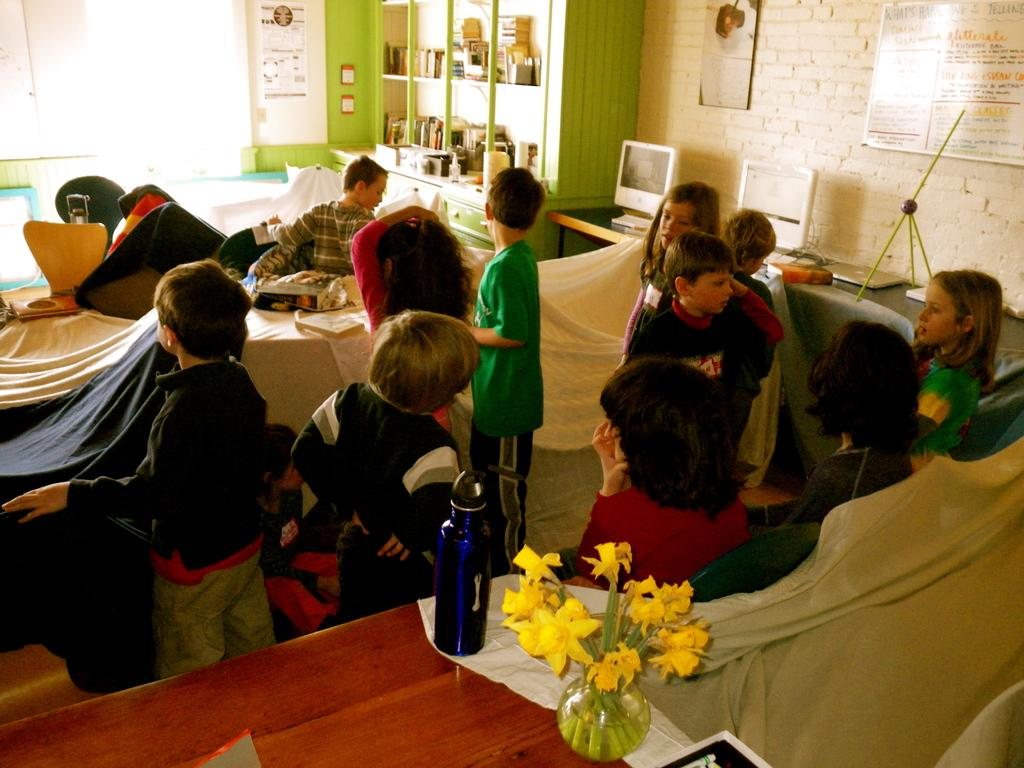How many people are in the room in the image? There are people in the room in the image, but the exact number is not specified. What are the people doing in the room? The people are playing with chairs and tables in the room. What can be seen besides the people and furniture in the image? There is a water bottle and a flower vase in the image. What is on the shelf in the image? There is a shelf with some things in the image, but the specific items are not described. What type of eggnog can be seen in the image? There is no eggnog present in the image. What kind of truck is parked outside the room in the image? There is no truck visible in the image; it only shows the interior of a room. 